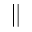<formula> <loc_0><loc_0><loc_500><loc_500>\|</formula> 